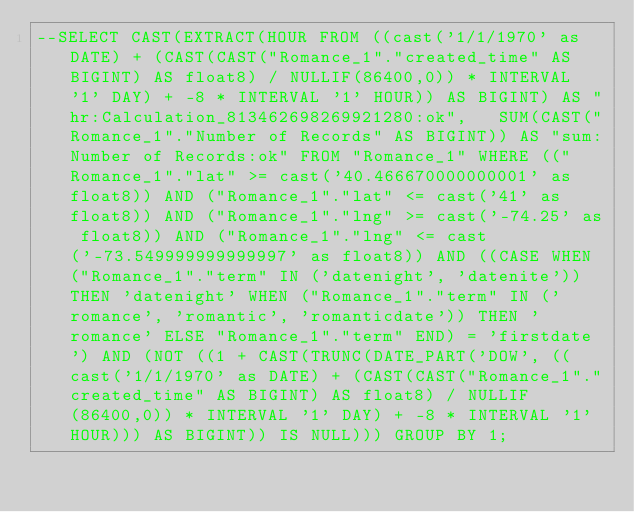Convert code to text. <code><loc_0><loc_0><loc_500><loc_500><_SQL_>--SELECT CAST(EXTRACT(HOUR FROM ((cast('1/1/1970' as DATE) + (CAST(CAST("Romance_1"."created_time" AS BIGINT) AS float8) / NULLIF(86400,0)) * INTERVAL '1' DAY) + -8 * INTERVAL '1' HOUR)) AS BIGINT) AS "hr:Calculation_813462698269921280:ok",   SUM(CAST("Romance_1"."Number of Records" AS BIGINT)) AS "sum:Number of Records:ok" FROM "Romance_1" WHERE (("Romance_1"."lat" >= cast('40.466670000000001' as float8)) AND ("Romance_1"."lat" <= cast('41' as float8)) AND ("Romance_1"."lng" >= cast('-74.25' as float8)) AND ("Romance_1"."lng" <= cast('-73.549999999999997' as float8)) AND ((CASE WHEN ("Romance_1"."term" IN ('datenight', 'datenite')) THEN 'datenight' WHEN ("Romance_1"."term" IN ('romance', 'romantic', 'romanticdate')) THEN 'romance' ELSE "Romance_1"."term" END) = 'firstdate') AND (NOT ((1 + CAST(TRUNC(DATE_PART('DOW', ((cast('1/1/1970' as DATE) + (CAST(CAST("Romance_1"."created_time" AS BIGINT) AS float8) / NULLIF(86400,0)) * INTERVAL '1' DAY) + -8 * INTERVAL '1' HOUR))) AS BIGINT)) IS NULL))) GROUP BY 1;
</code> 